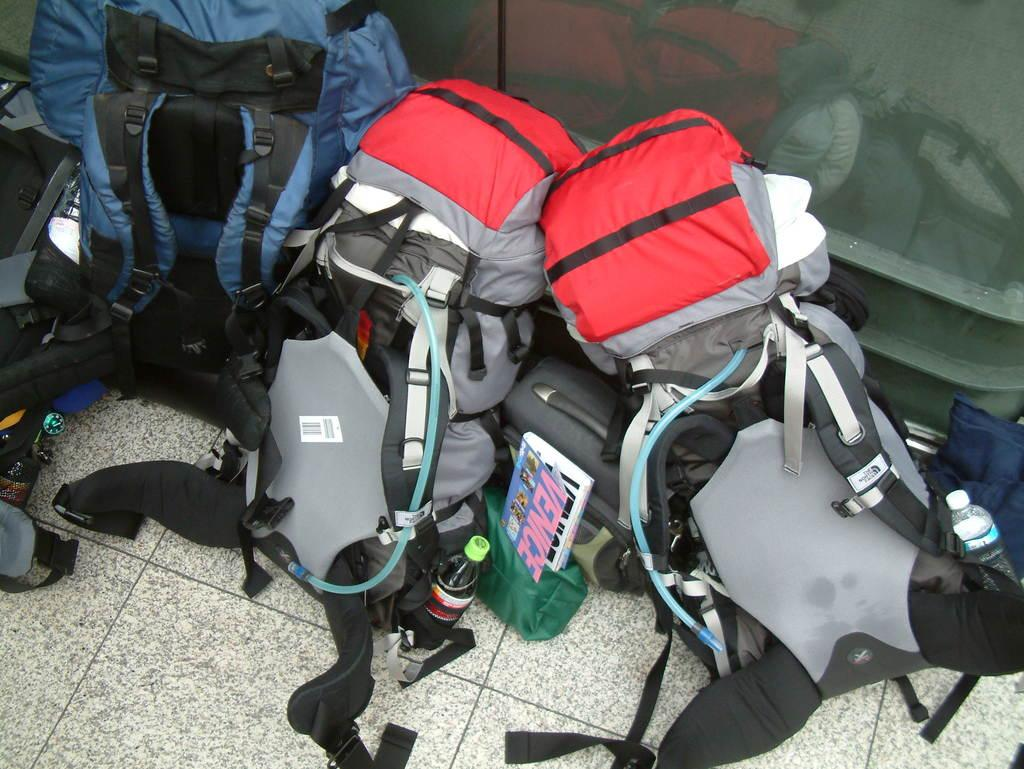What type of bags are visible in the image? There are travelling bags in the image. Where are the travelling bags placed? The travelling bags are kept on the ground. What type of glove can be seen in the image? There is no glove present in the image. What view can be seen from the top of the travelling bags? The image does not provide a view from the top of the travelling bags, as they are on the ground. 